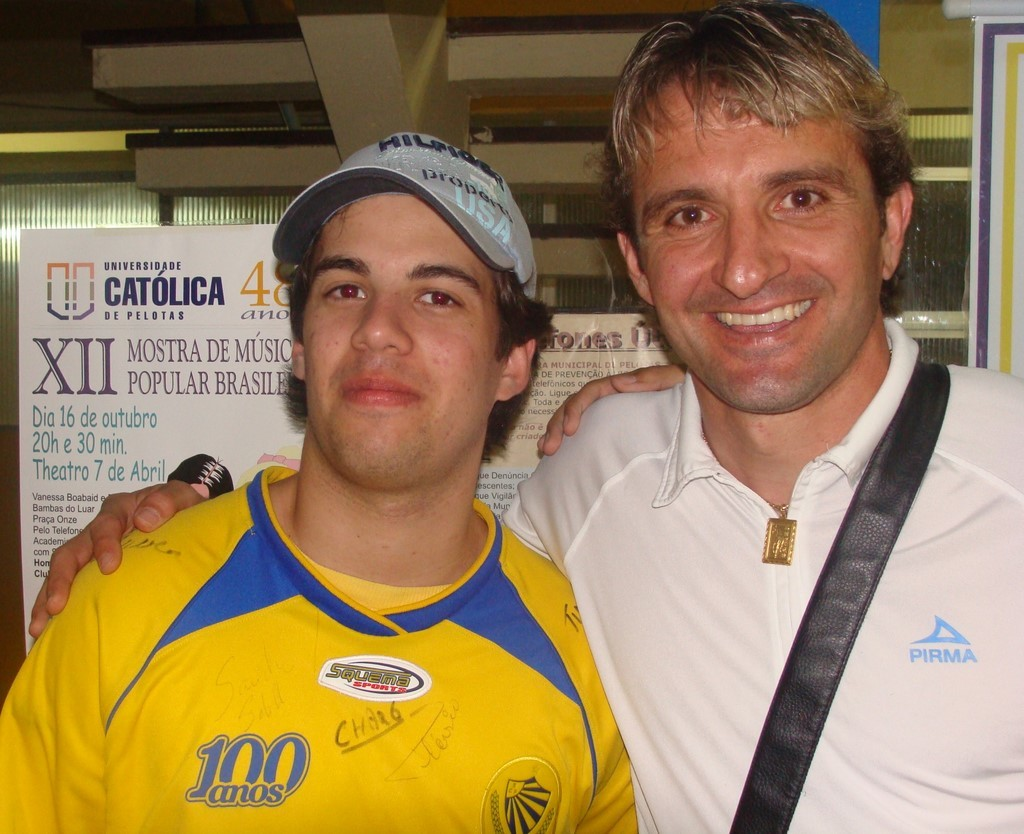Provide a one-sentence caption for the provided image. Two men, one in a yellow jersey signed with '100 anos' and various autographs, celebrating an important milestone at a music event, with a backdrop promoting the 'XII Mostra de Música Popular Brasileira' held at Theatro 7 de Abril. 